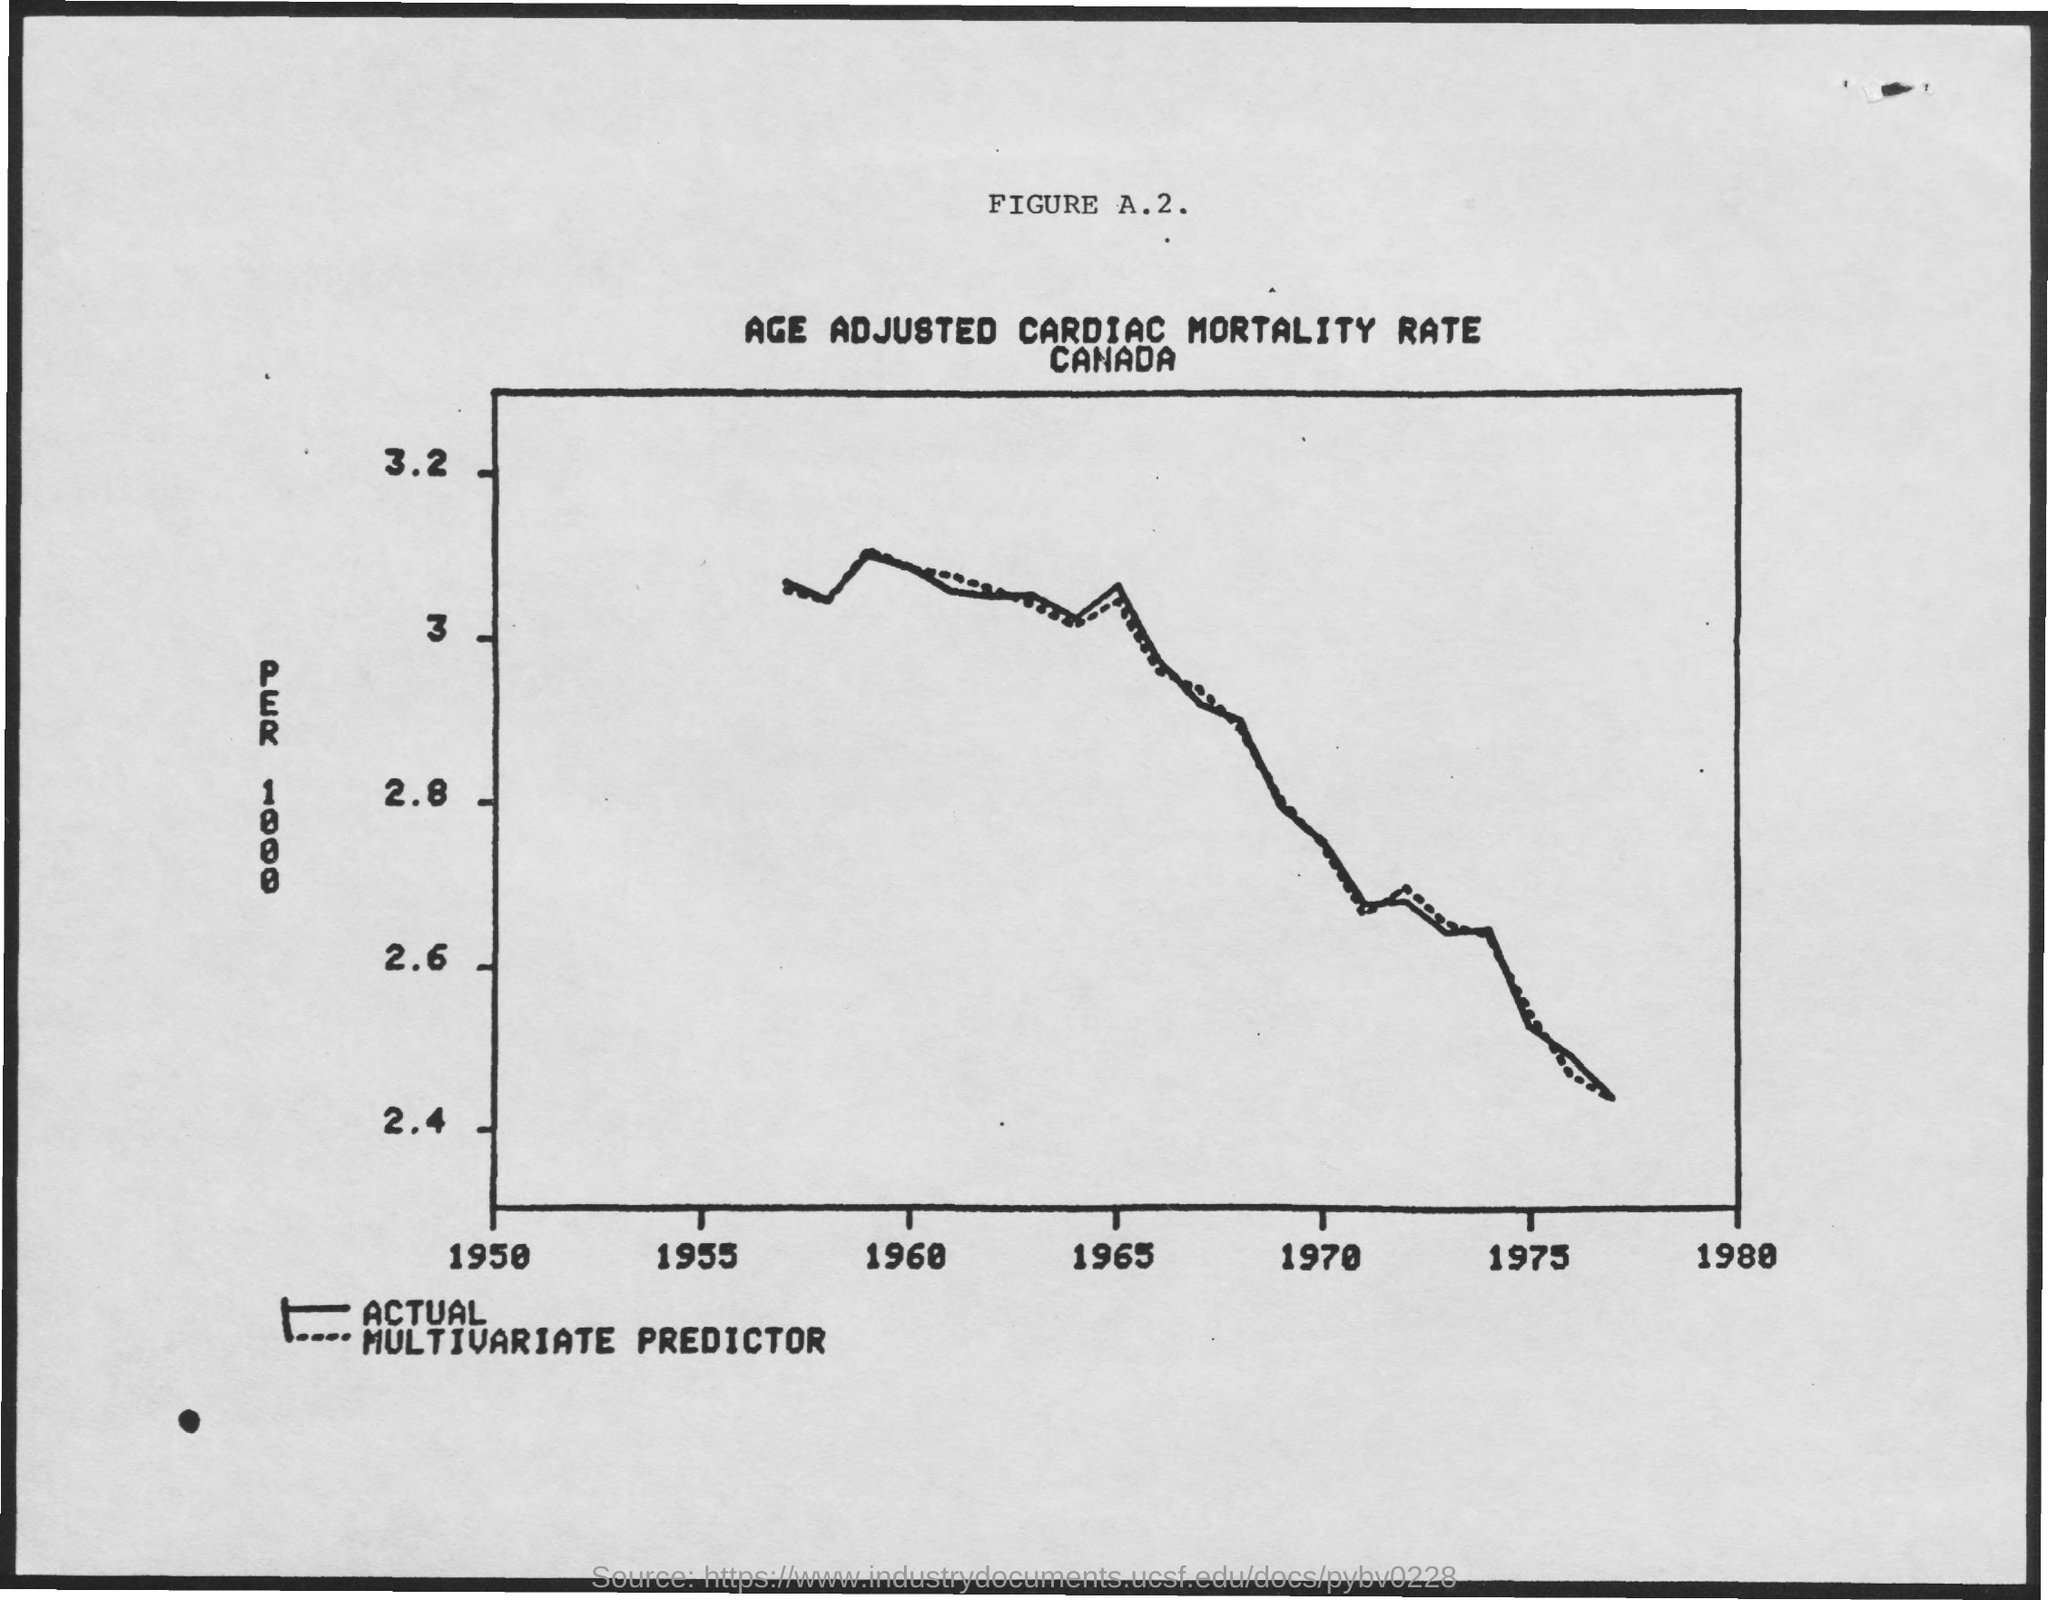Indicate a few pertinent items in this graphic. The country mentioned in the document is Canada. 